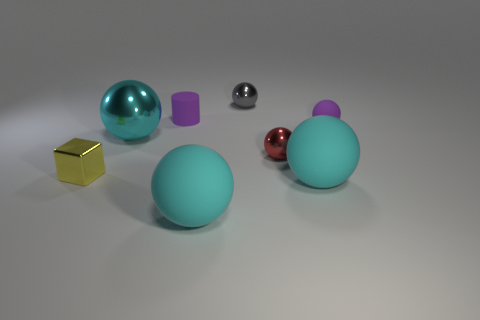Does the purple matte ball have the same size as the cyan metal ball?
Your answer should be compact. No. How many objects are gray metallic things or cyan metal balls?
Offer a very short reply. 2. Are there the same number of red things on the left side of the matte cylinder and red metal spheres?
Make the answer very short. No. Is there a large rubber thing that is in front of the shiny thing that is to the left of the big cyan thing behind the tiny yellow block?
Offer a terse response. Yes. What is the color of the tiny sphere that is made of the same material as the cylinder?
Your response must be concise. Purple. There is a metal sphere behind the cyan metallic sphere; does it have the same color as the tiny cylinder?
Your answer should be compact. No. How many balls are blue objects or small red things?
Your answer should be very brief. 1. There is a matte sphere on the right side of the large thing to the right of the tiny metallic sphere in front of the big shiny ball; what is its size?
Your answer should be compact. Small. There is a purple rubber thing that is the same size as the purple cylinder; what is its shape?
Provide a succinct answer. Sphere. What is the shape of the small red metallic thing?
Your response must be concise. Sphere. 